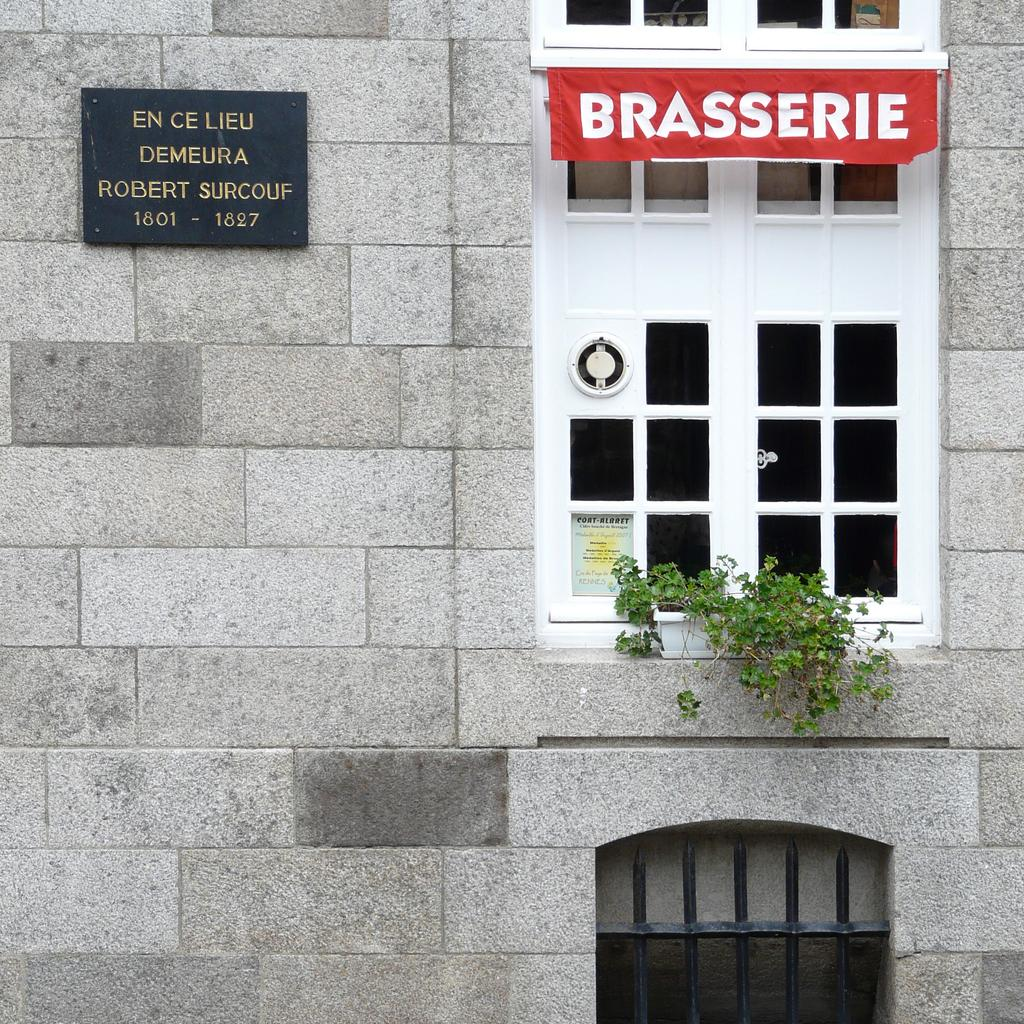What type of structure is visible in the image? There is a wall of a building in the image. What architectural features can be seen on the building? There are windows visible on the building. Is there any vegetation present in the image? Yes, there is a plant in the image. What is written or displayed on the boards in the image? There is text on boards in the image. How many feet are visible in the image? There are no feet visible in the image. Is there any evidence of war or conflict in the image? There is no evidence of war or conflict in the image. Did an earthquake cause any damage to the building in the image? There is no indication of an earthquake or any damage to the building in the image. 